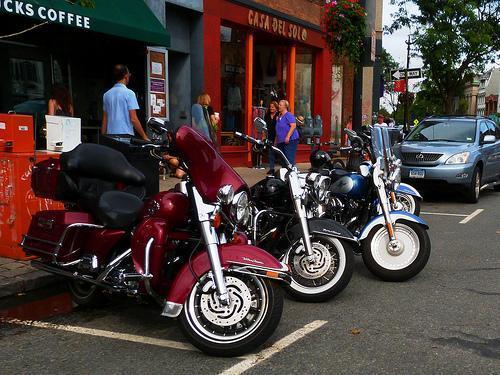How many bikes are there?
Give a very brief answer. 4. 